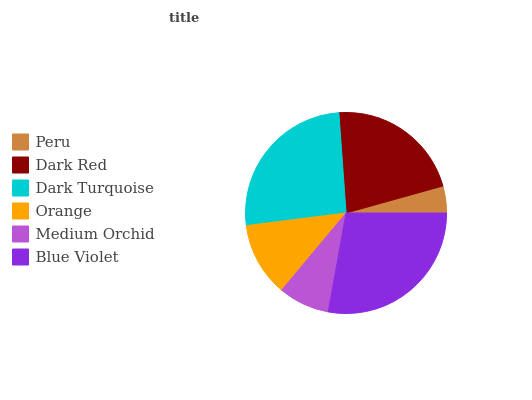Is Peru the minimum?
Answer yes or no. Yes. Is Blue Violet the maximum?
Answer yes or no. Yes. Is Dark Red the minimum?
Answer yes or no. No. Is Dark Red the maximum?
Answer yes or no. No. Is Dark Red greater than Peru?
Answer yes or no. Yes. Is Peru less than Dark Red?
Answer yes or no. Yes. Is Peru greater than Dark Red?
Answer yes or no. No. Is Dark Red less than Peru?
Answer yes or no. No. Is Dark Red the high median?
Answer yes or no. Yes. Is Orange the low median?
Answer yes or no. Yes. Is Orange the high median?
Answer yes or no. No. Is Medium Orchid the low median?
Answer yes or no. No. 